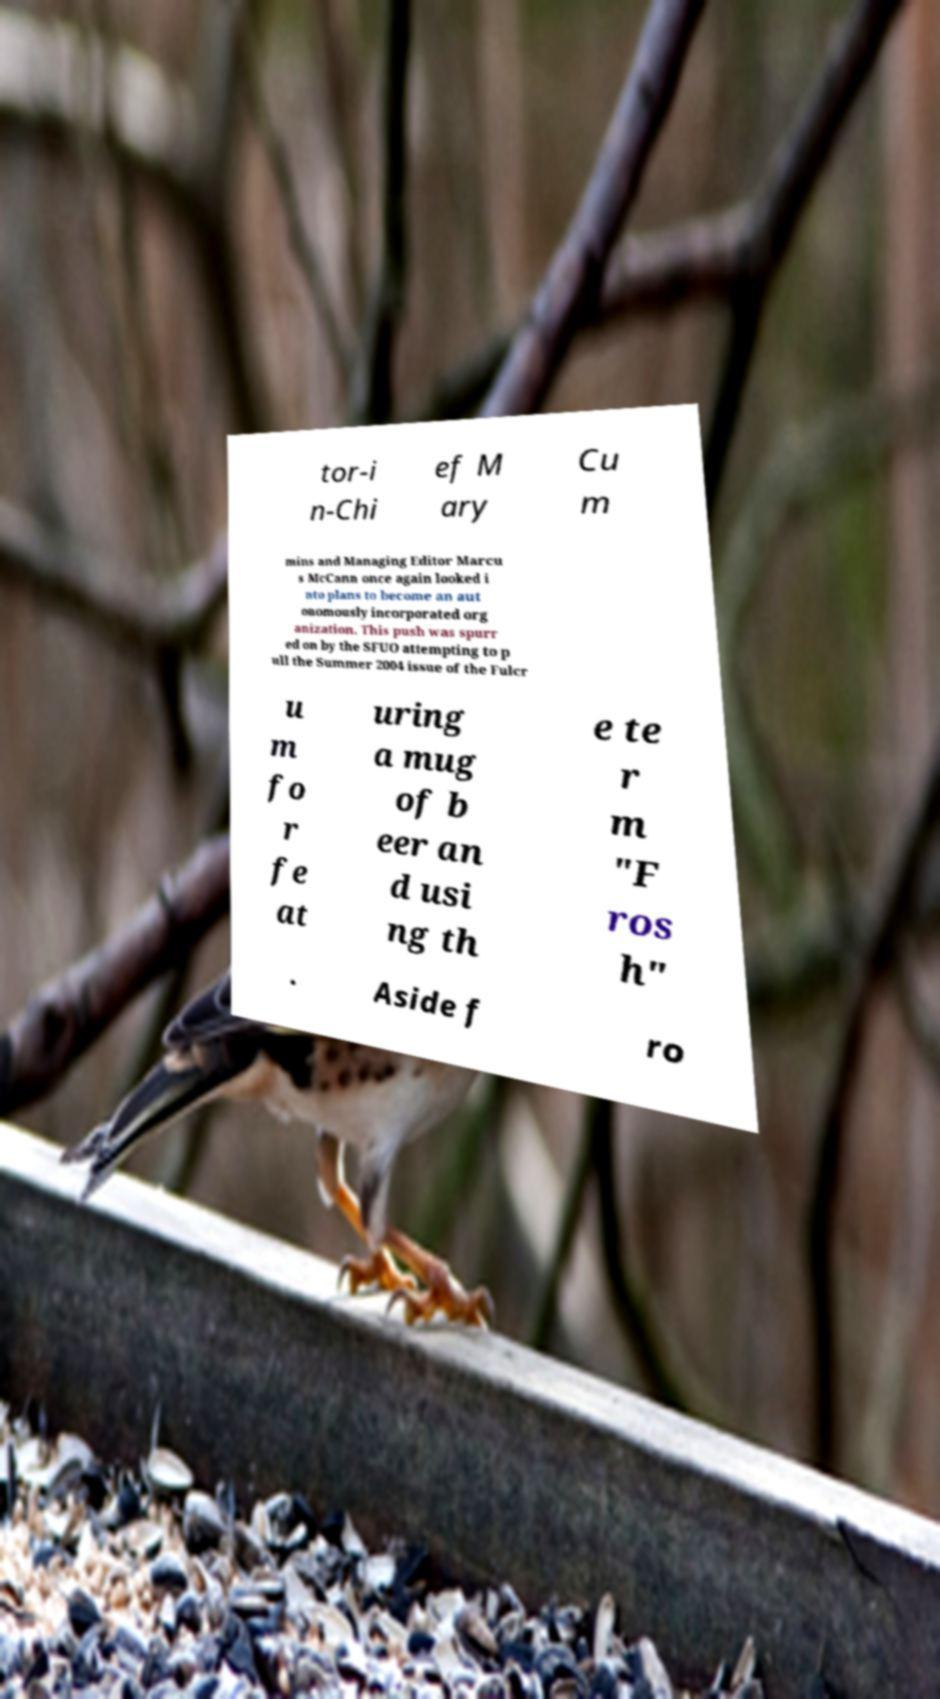Could you assist in decoding the text presented in this image and type it out clearly? tor-i n-Chi ef M ary Cu m mins and Managing Editor Marcu s McCann once again looked i nto plans to become an aut onomously incorporated org anization. This push was spurr ed on by the SFUO attempting to p ull the Summer 2004 issue of the Fulcr u m fo r fe at uring a mug of b eer an d usi ng th e te r m "F ros h" . Aside f ro 